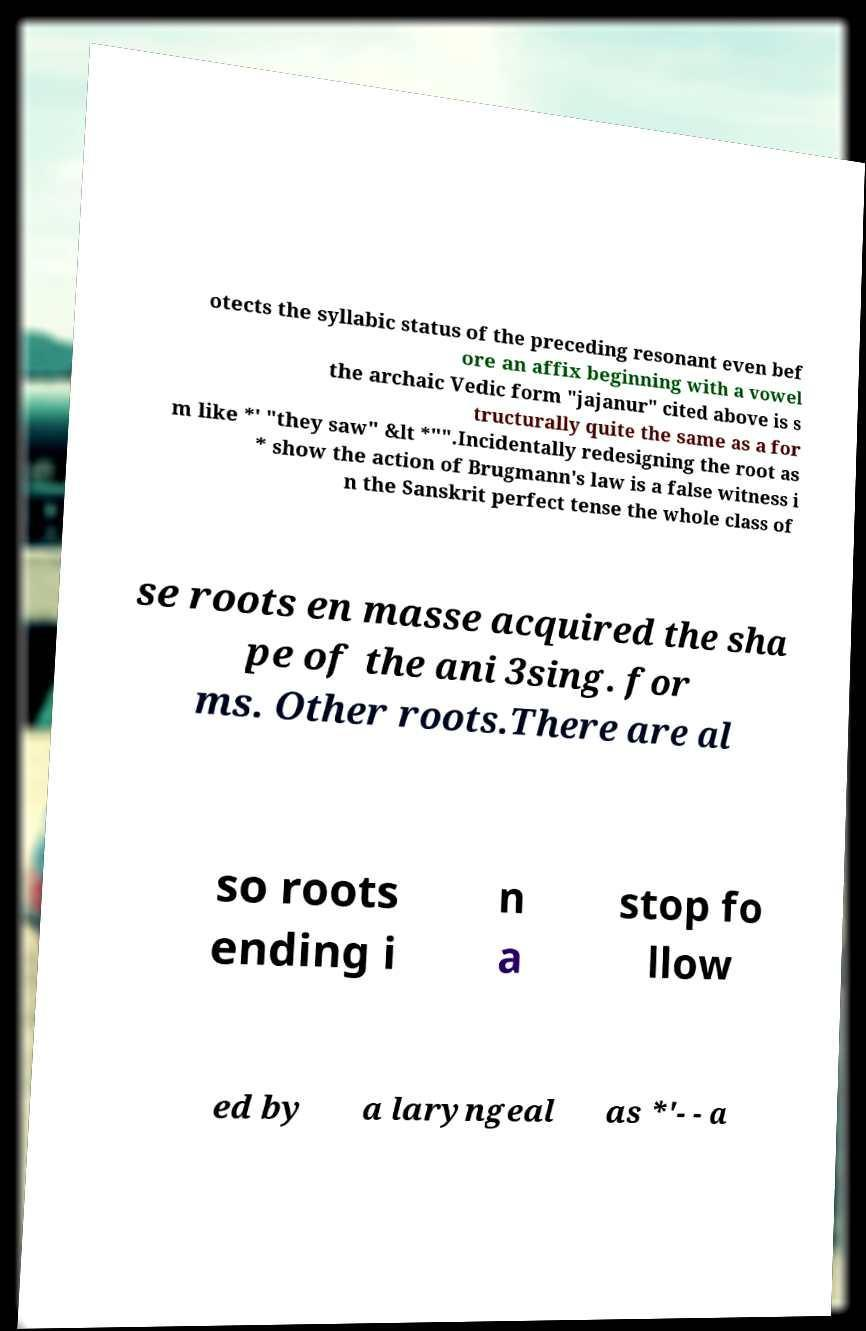Please read and relay the text visible in this image. What does it say? otects the syllabic status of the preceding resonant even bef ore an affix beginning with a vowel the archaic Vedic form "jajanur" cited above is s tructurally quite the same as a for m like *' "they saw" &lt *"".Incidentally redesigning the root as * show the action of Brugmann's law is a false witness i n the Sanskrit perfect tense the whole class of se roots en masse acquired the sha pe of the ani 3sing. for ms. Other roots.There are al so roots ending i n a stop fo llow ed by a laryngeal as *'- - a 